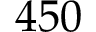<formula> <loc_0><loc_0><loc_500><loc_500>4 5 0</formula> 